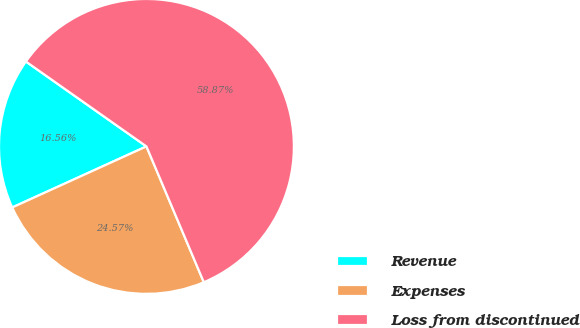Convert chart. <chart><loc_0><loc_0><loc_500><loc_500><pie_chart><fcel>Revenue<fcel>Expenses<fcel>Loss from discontinued<nl><fcel>16.56%<fcel>24.57%<fcel>58.87%<nl></chart> 